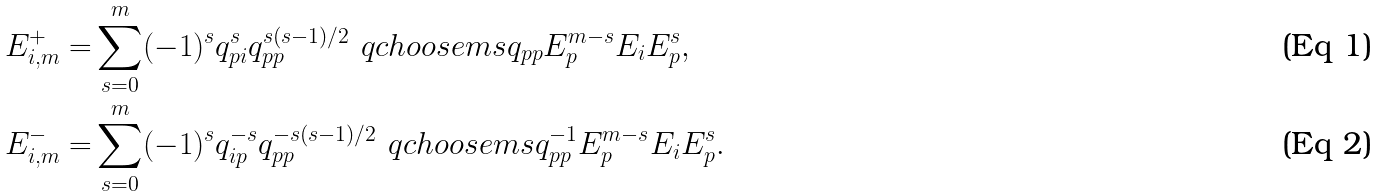Convert formula to latex. <formula><loc_0><loc_0><loc_500><loc_500>E ^ { + } _ { i , m } = & \sum _ { s = 0 } ^ { m } ( - 1 ) ^ { s } q _ { p i } ^ { s } q _ { p p } ^ { s ( s - 1 ) / 2 } \ q c h o o s e { m } { s } { q _ { p p } } E _ { p } ^ { m - s } E _ { i } E _ { p } ^ { s } , \\ E ^ { - } _ { i , m } = & \sum _ { s = 0 } ^ { m } ( - 1 ) ^ { s } q _ { i p } ^ { - s } q _ { p p } ^ { - s ( s - 1 ) / 2 } \ q c h o o s e { m } { s } { q _ { p p } ^ { - 1 } } E _ { p } ^ { m - s } E _ { i } E _ { p } ^ { s } .</formula> 